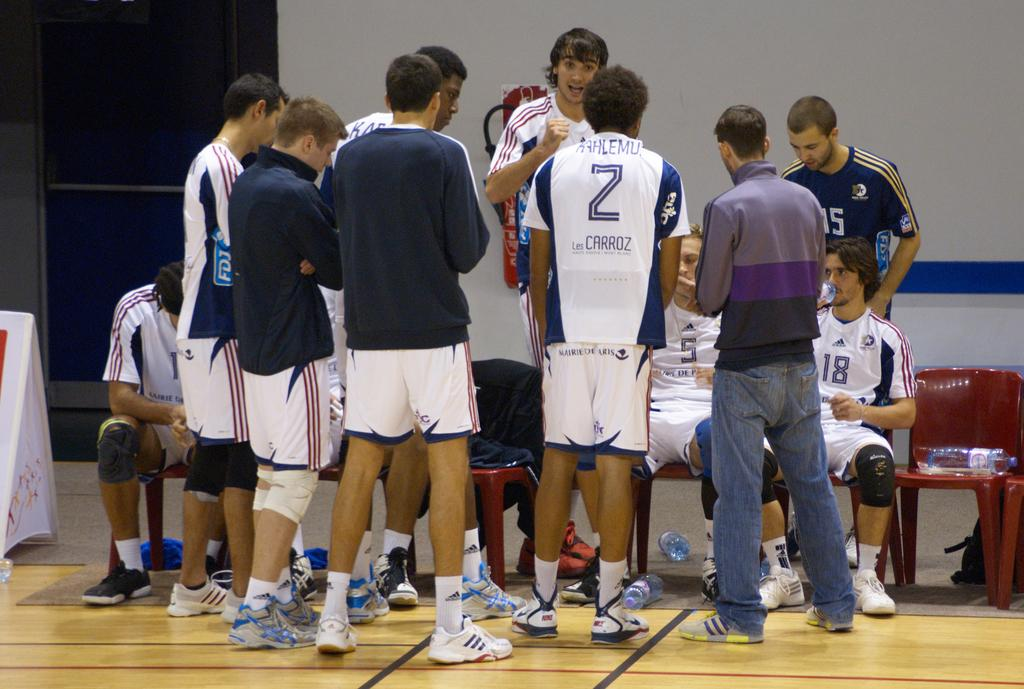<image>
Relay a brief, clear account of the picture shown. Several athletes are in a huddle with one having the number two on his back. 